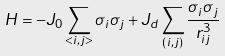<formula> <loc_0><loc_0><loc_500><loc_500>H = - J _ { 0 } \sum _ { < i , j > } { \sigma _ { i } \sigma _ { j } } + J _ { d } \sum _ { ( i , j ) } { \frac { \sigma _ { i } \sigma _ { j } } { r _ { i j } ^ { 3 } } }</formula> 